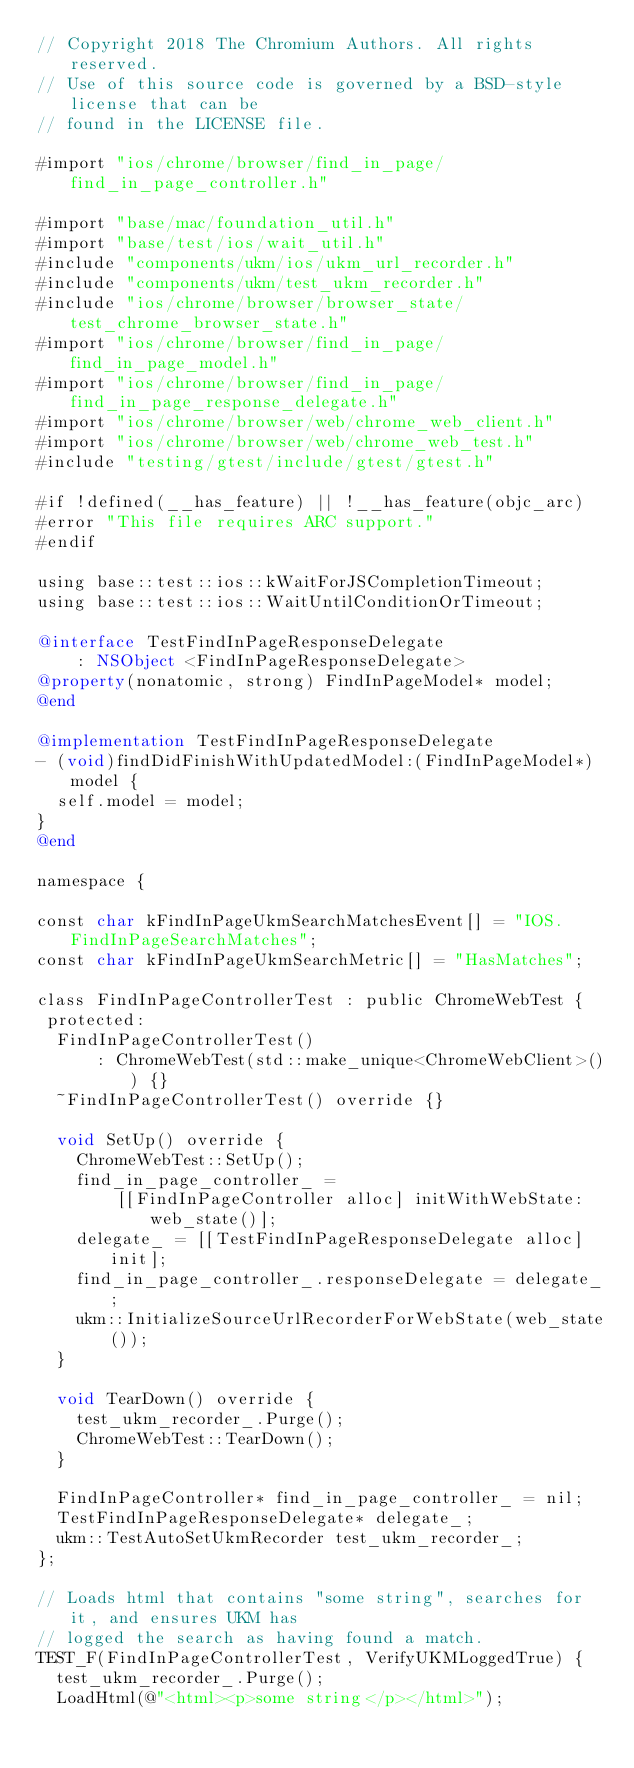<code> <loc_0><loc_0><loc_500><loc_500><_ObjectiveC_>// Copyright 2018 The Chromium Authors. All rights reserved.
// Use of this source code is governed by a BSD-style license that can be
// found in the LICENSE file.

#import "ios/chrome/browser/find_in_page/find_in_page_controller.h"

#import "base/mac/foundation_util.h"
#import "base/test/ios/wait_util.h"
#include "components/ukm/ios/ukm_url_recorder.h"
#include "components/ukm/test_ukm_recorder.h"
#include "ios/chrome/browser/browser_state/test_chrome_browser_state.h"
#import "ios/chrome/browser/find_in_page/find_in_page_model.h"
#import "ios/chrome/browser/find_in_page/find_in_page_response_delegate.h"
#import "ios/chrome/browser/web/chrome_web_client.h"
#import "ios/chrome/browser/web/chrome_web_test.h"
#include "testing/gtest/include/gtest/gtest.h"

#if !defined(__has_feature) || !__has_feature(objc_arc)
#error "This file requires ARC support."
#endif

using base::test::ios::kWaitForJSCompletionTimeout;
using base::test::ios::WaitUntilConditionOrTimeout;

@interface TestFindInPageResponseDelegate
    : NSObject <FindInPageResponseDelegate>
@property(nonatomic, strong) FindInPageModel* model;
@end

@implementation TestFindInPageResponseDelegate
- (void)findDidFinishWithUpdatedModel:(FindInPageModel*)model {
  self.model = model;
}
@end

namespace {

const char kFindInPageUkmSearchMatchesEvent[] = "IOS.FindInPageSearchMatches";
const char kFindInPageUkmSearchMetric[] = "HasMatches";

class FindInPageControllerTest : public ChromeWebTest {
 protected:
  FindInPageControllerTest()
      : ChromeWebTest(std::make_unique<ChromeWebClient>()) {}
  ~FindInPageControllerTest() override {}

  void SetUp() override {
    ChromeWebTest::SetUp();
    find_in_page_controller_ =
        [[FindInPageController alloc] initWithWebState:web_state()];
    delegate_ = [[TestFindInPageResponseDelegate alloc] init];
    find_in_page_controller_.responseDelegate = delegate_;
    ukm::InitializeSourceUrlRecorderForWebState(web_state());
  }

  void TearDown() override {
    test_ukm_recorder_.Purge();
    ChromeWebTest::TearDown();
  }

  FindInPageController* find_in_page_controller_ = nil;
  TestFindInPageResponseDelegate* delegate_;
  ukm::TestAutoSetUkmRecorder test_ukm_recorder_;
};

// Loads html that contains "some string", searches for it, and ensures UKM has
// logged the search as having found a match.
TEST_F(FindInPageControllerTest, VerifyUKMLoggedTrue) {
  test_ukm_recorder_.Purge();
  LoadHtml(@"<html><p>some string</p></html>");</code> 